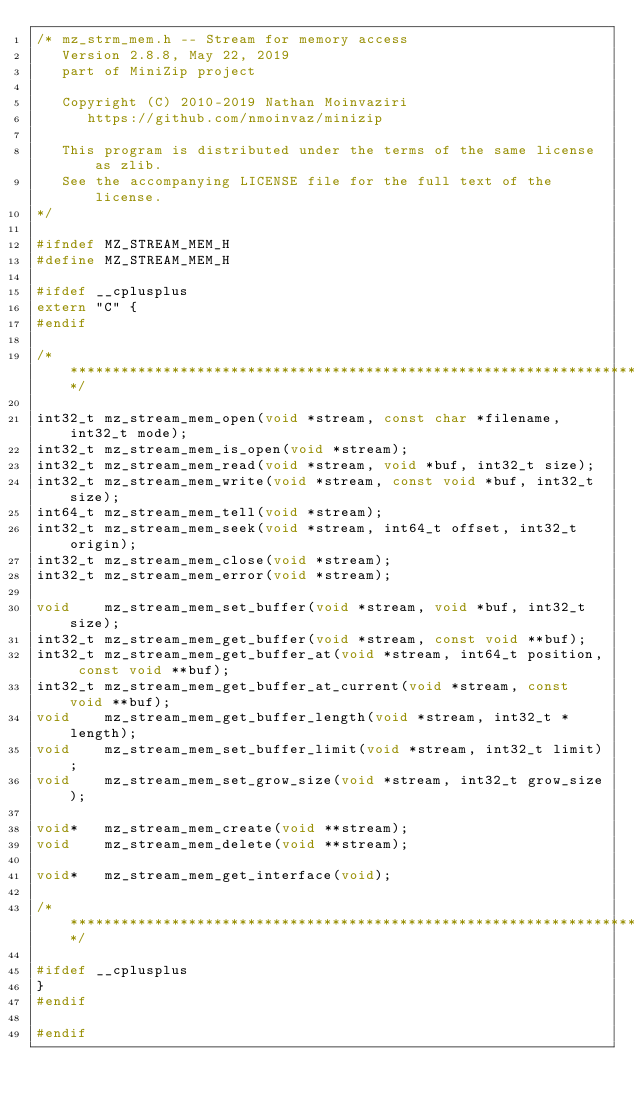<code> <loc_0><loc_0><loc_500><loc_500><_C_>/* mz_strm_mem.h -- Stream for memory access
   Version 2.8.8, May 22, 2019
   part of MiniZip project

   Copyright (C) 2010-2019 Nathan Moinvaziri
      https://github.com/nmoinvaz/minizip

   This program is distributed under the terms of the same license as zlib.
   See the accompanying LICENSE file for the full text of the license.
*/

#ifndef MZ_STREAM_MEM_H
#define MZ_STREAM_MEM_H

#ifdef __cplusplus
extern "C" {
#endif

/***************************************************************************/

int32_t mz_stream_mem_open(void *stream, const char *filename, int32_t mode);
int32_t mz_stream_mem_is_open(void *stream);
int32_t mz_stream_mem_read(void *stream, void *buf, int32_t size);
int32_t mz_stream_mem_write(void *stream, const void *buf, int32_t size);
int64_t mz_stream_mem_tell(void *stream);
int32_t mz_stream_mem_seek(void *stream, int64_t offset, int32_t origin);
int32_t mz_stream_mem_close(void *stream);
int32_t mz_stream_mem_error(void *stream);

void    mz_stream_mem_set_buffer(void *stream, void *buf, int32_t size);
int32_t mz_stream_mem_get_buffer(void *stream, const void **buf);
int32_t mz_stream_mem_get_buffer_at(void *stream, int64_t position, const void **buf);
int32_t mz_stream_mem_get_buffer_at_current(void *stream, const void **buf);
void    mz_stream_mem_get_buffer_length(void *stream, int32_t *length);
void    mz_stream_mem_set_buffer_limit(void *stream, int32_t limit);
void    mz_stream_mem_set_grow_size(void *stream, int32_t grow_size);

void*   mz_stream_mem_create(void **stream);
void    mz_stream_mem_delete(void **stream);

void*   mz_stream_mem_get_interface(void);

/***************************************************************************/

#ifdef __cplusplus
}
#endif

#endif
</code> 